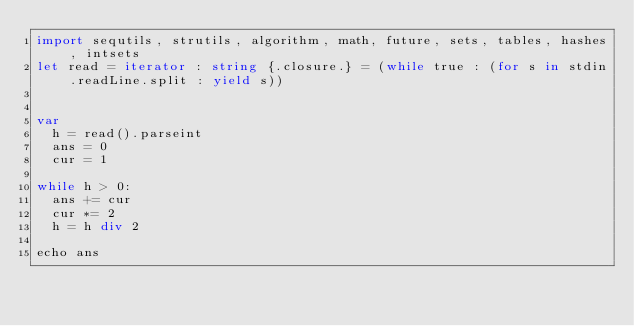Convert code to text. <code><loc_0><loc_0><loc_500><loc_500><_Nim_>import sequtils, strutils, algorithm, math, future, sets, tables, hashes, intsets
let read = iterator : string {.closure.} = (while true : (for s in stdin.readLine.split : yield s))


var
  h = read().parseint
  ans = 0
  cur = 1

while h > 0:
  ans += cur
  cur *= 2
  h = h div 2

echo ans



</code> 